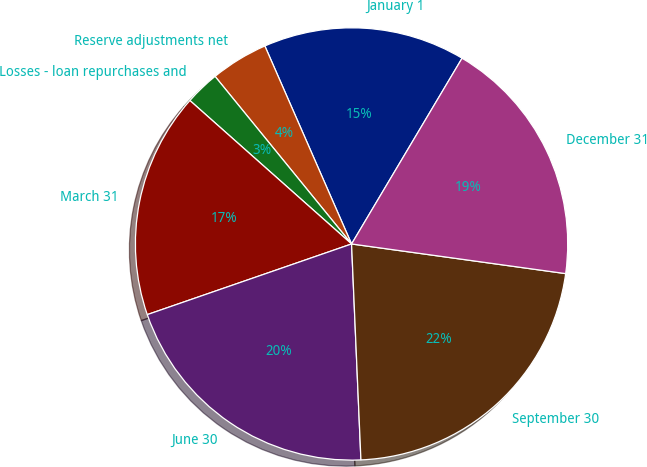Convert chart. <chart><loc_0><loc_0><loc_500><loc_500><pie_chart><fcel>January 1<fcel>Reserve adjustments net<fcel>Losses - loan repurchases and<fcel>March 31<fcel>June 30<fcel>September 30<fcel>December 31<nl><fcel>15.11%<fcel>4.31%<fcel>2.57%<fcel>16.85%<fcel>20.39%<fcel>22.12%<fcel>18.65%<nl></chart> 